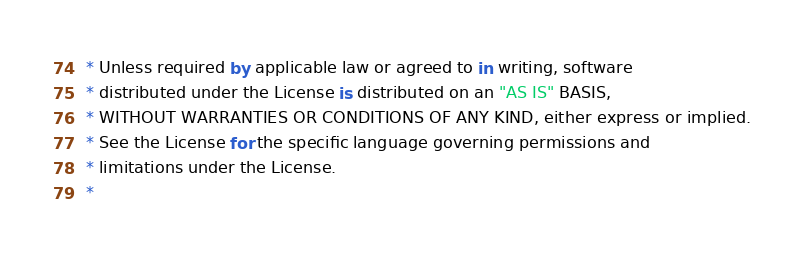Convert code to text. <code><loc_0><loc_0><loc_500><loc_500><_Kotlin_> * Unless required by applicable law or agreed to in writing, software
 * distributed under the License is distributed on an "AS IS" BASIS,
 * WITHOUT WARRANTIES OR CONDITIONS OF ANY KIND, either express or implied.
 * See the License for the specific language governing permissions and
 * limitations under the License.
 *</code> 